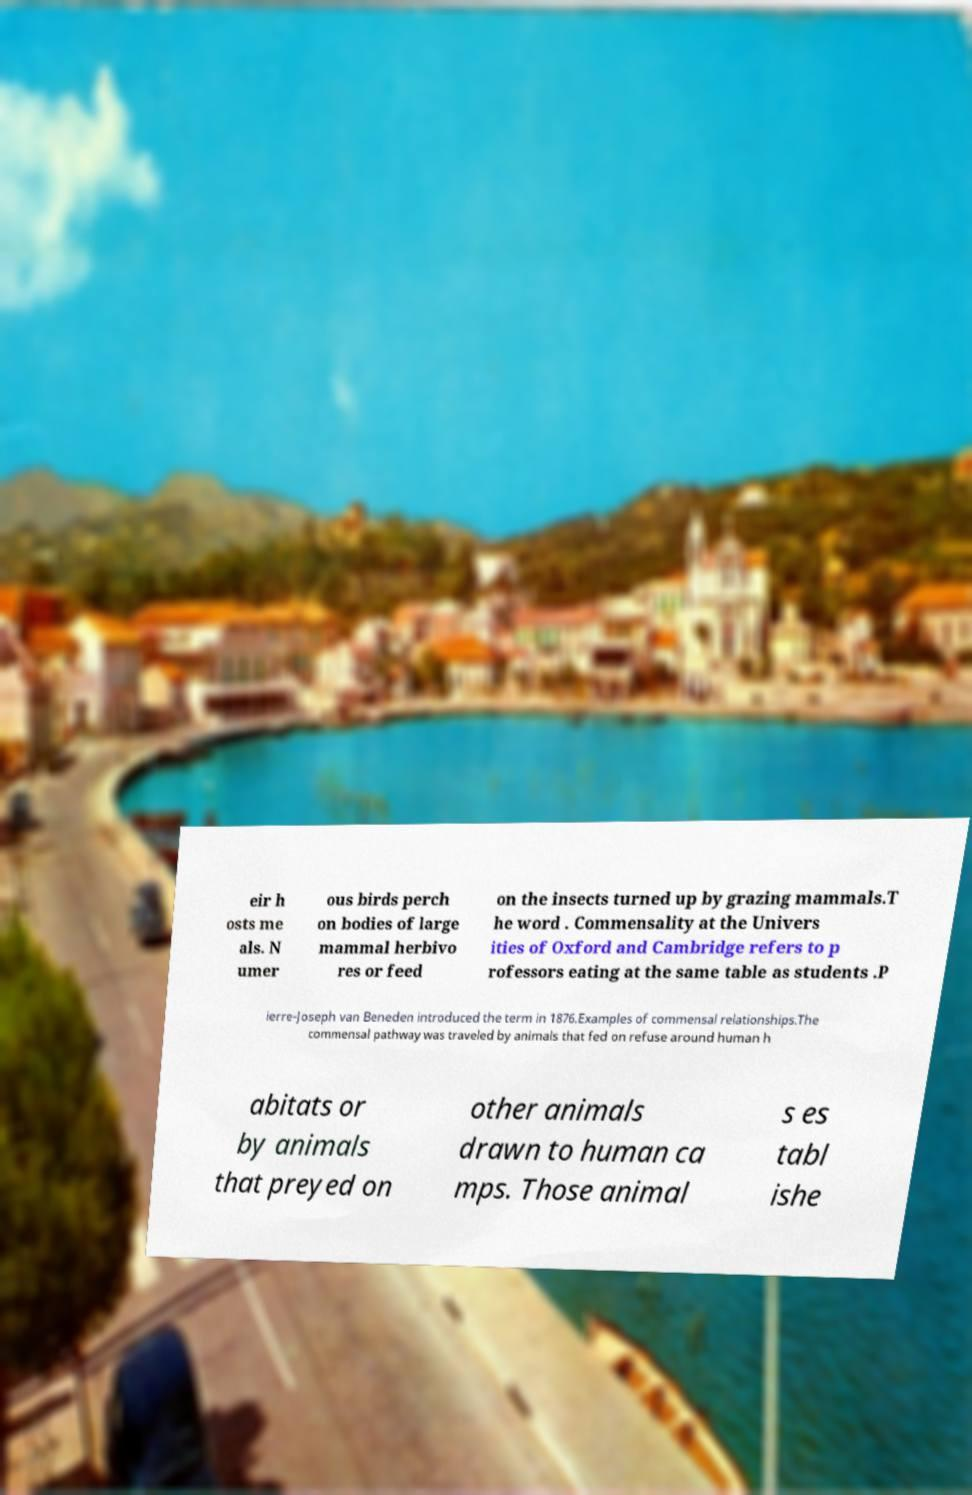There's text embedded in this image that I need extracted. Can you transcribe it verbatim? eir h osts me als. N umer ous birds perch on bodies of large mammal herbivo res or feed on the insects turned up by grazing mammals.T he word . Commensality at the Univers ities of Oxford and Cambridge refers to p rofessors eating at the same table as students .P ierre-Joseph van Beneden introduced the term in 1876.Examples of commensal relationships.The commensal pathway was traveled by animals that fed on refuse around human h abitats or by animals that preyed on other animals drawn to human ca mps. Those animal s es tabl ishe 